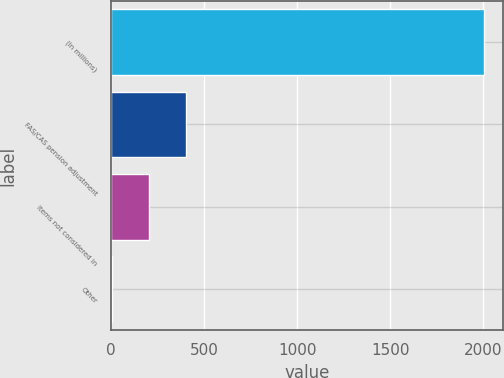<chart> <loc_0><loc_0><loc_500><loc_500><bar_chart><fcel>(In millions)<fcel>FAS/CAS pension adjustment<fcel>Items not considered in<fcel>Other<nl><fcel>2003<fcel>403.8<fcel>203.9<fcel>4<nl></chart> 